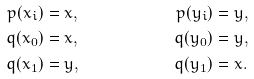Convert formula to latex. <formula><loc_0><loc_0><loc_500><loc_500>& & & & & & p ( x _ { i } ) & = x , & p ( y _ { i } ) & = y , & & & & & & \\ & & & & & & q ( x _ { 0 } ) & = x , & q ( y _ { 0 } ) & = y , & & & & & & \\ & & & & & & q ( x _ { 1 } ) & = y , & q ( y _ { 1 } ) & = x . & & & & & &</formula> 